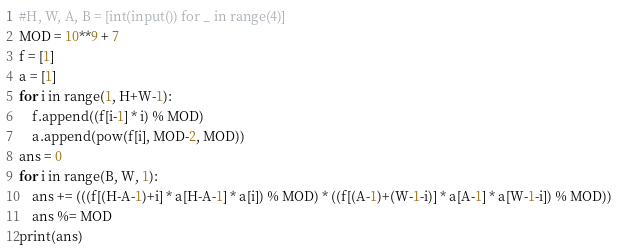Convert code to text. <code><loc_0><loc_0><loc_500><loc_500><_Python_>#H, W, A, B = [int(input()) for _ in range(4)]
MOD = 10**9 + 7
f = [1]
a = [1]
for i in range(1, H+W-1):
    f.append((f[i-1] * i) % MOD)
    a.append(pow(f[i], MOD-2, MOD))
ans = 0
for i in range(B, W, 1):
    ans += (((f[(H-A-1)+i] * a[H-A-1] * a[i]) % MOD) * ((f[(A-1)+(W-1-i)] * a[A-1] * a[W-1-i]) % MOD))
    ans %= MOD
print(ans)</code> 